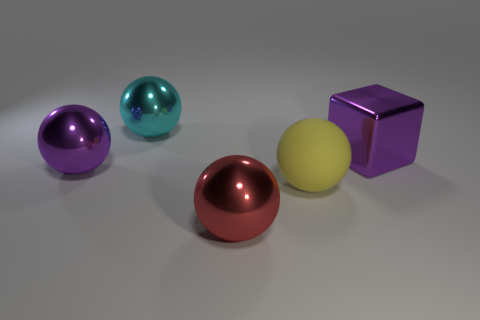There is a metallic thing that is the same color as the cube; what is its shape?
Your answer should be very brief. Sphere. Does the big red sphere have the same material as the big cyan ball?
Your answer should be very brief. Yes. What number of shiny objects are right of the big purple metal object that is on the left side of the metallic object behind the metallic block?
Your answer should be compact. 3. What is the shape of the big purple thing in front of the big metal block?
Provide a short and direct response. Sphere. How many other objects are the same material as the large block?
Keep it short and to the point. 3. Does the big matte ball have the same color as the metallic block?
Provide a short and direct response. No. Is the number of purple shiny blocks in front of the matte sphere less than the number of large balls that are behind the large purple block?
Offer a terse response. Yes. What is the color of the big rubber thing that is the same shape as the red metal thing?
Your response must be concise. Yellow. Is the size of the metallic thing that is in front of the purple sphere the same as the large purple shiny cube?
Provide a short and direct response. Yes. Are there fewer shiny spheres left of the cyan object than cyan shiny spheres?
Offer a terse response. No. 